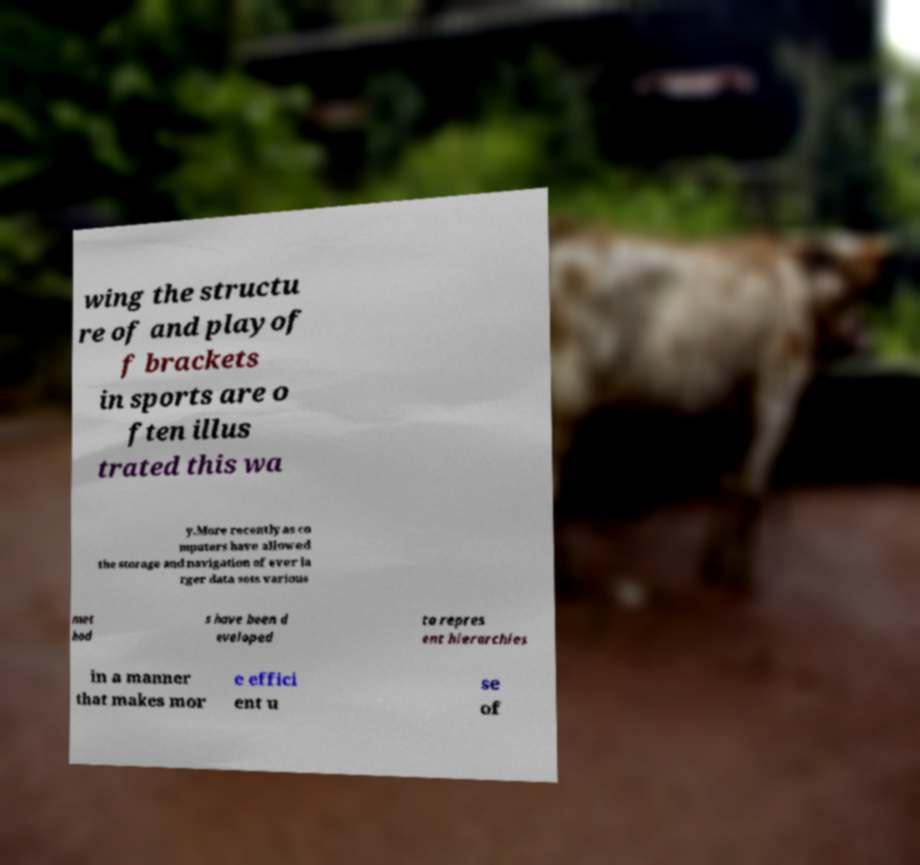Could you assist in decoding the text presented in this image and type it out clearly? wing the structu re of and playof f brackets in sports are o ften illus trated this wa y.More recently as co mputers have allowed the storage and navigation of ever la rger data sets various met hod s have been d eveloped to repres ent hierarchies in a manner that makes mor e effici ent u se of 